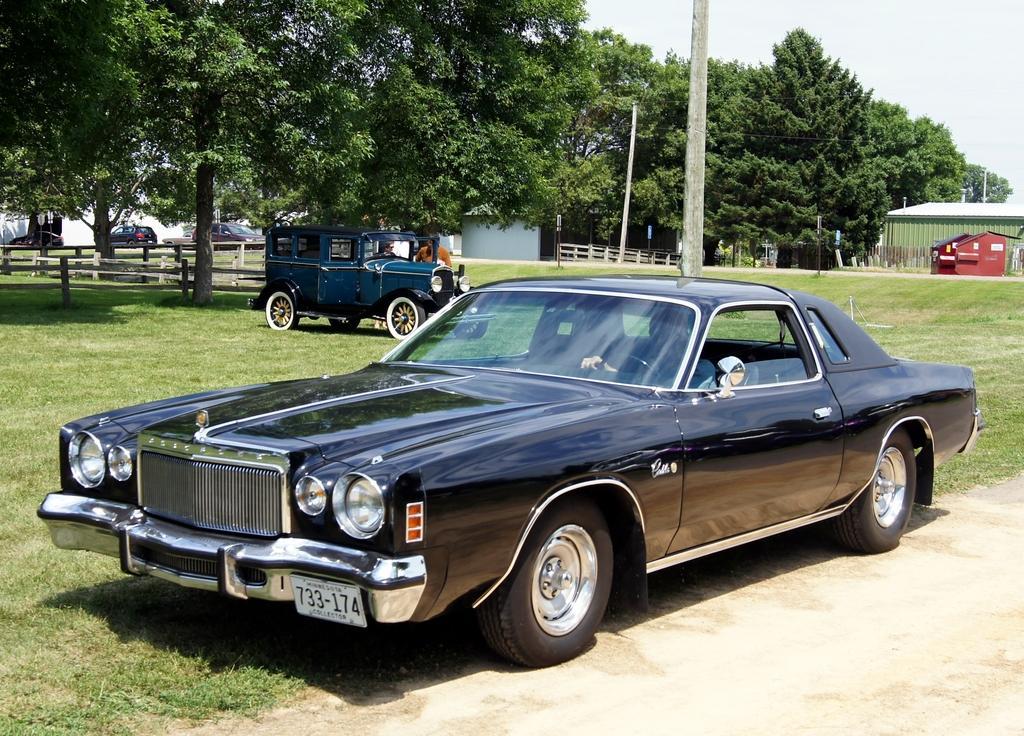Please provide a concise description of this image. In this image we can see a person inside the car. We can also see the vehicles, people, wooden barriers and also the poles. We can also see the house, trees, path and also the grass. Sky is also visible. 